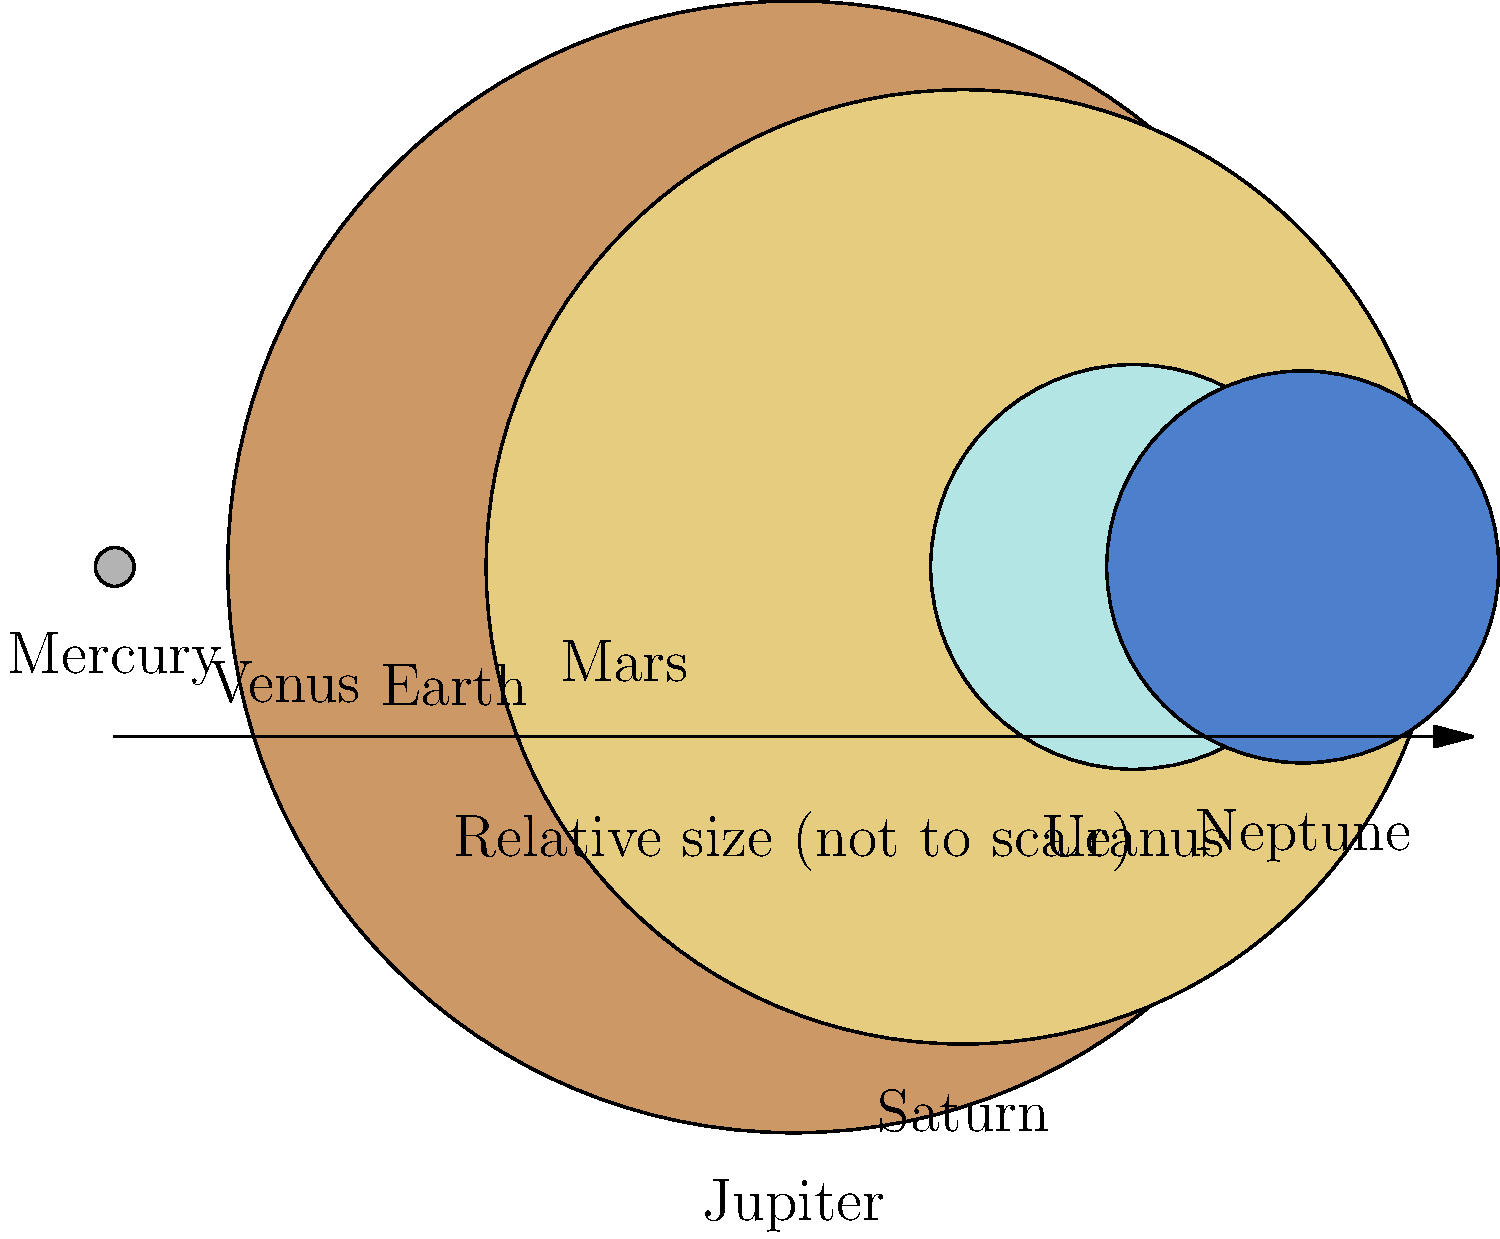Considering the scaled diagram of our solar system's planets, which would be the most suitable canvas size for Ester Šimerová-Martinčeková to paint Jupiter if she were to maintain the same relative proportions and use a 10 cm diameter circle for Earth? To solve this problem, we need to follow these steps:

1. Identify the relative sizes of Earth and Jupiter from the diagram:
   Earth's diameter: 12.8 units
   Jupiter's diameter: 142.9 units

2. Calculate the ratio of Jupiter's size to Earth's size:
   $\frac{142.9}{12.8} \approx 11.16$

3. Given that Earth is represented by a 10 cm diameter circle, calculate Jupiter's diameter:
   Jupiter's diameter = $10 \text{ cm} \times 11.16 = 111.6 \text{ cm}$

4. To determine a suitable canvas size, we should add some space around the planet. A good rule of thumb is to add about 20% on each side. So, we'll increase the size by 40%:
   Canvas size = $111.6 \text{ cm} \times 1.4 \approx 156.24 \text{ cm}$

5. Round up to the nearest standard canvas size, which would be 160 cm x 160 cm.

This size would allow Ester Šimerová-Martinčeková to paint Jupiter while maintaining the correct proportions relative to Earth, and provide enough space for any additional artistic elements or background.
Answer: 160 cm x 160 cm canvas 